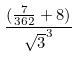Convert formula to latex. <formula><loc_0><loc_0><loc_500><loc_500>\frac { ( \frac { 7 } { 3 6 2 } + 8 ) } { \sqrt { 3 } ^ { 3 } }</formula> 